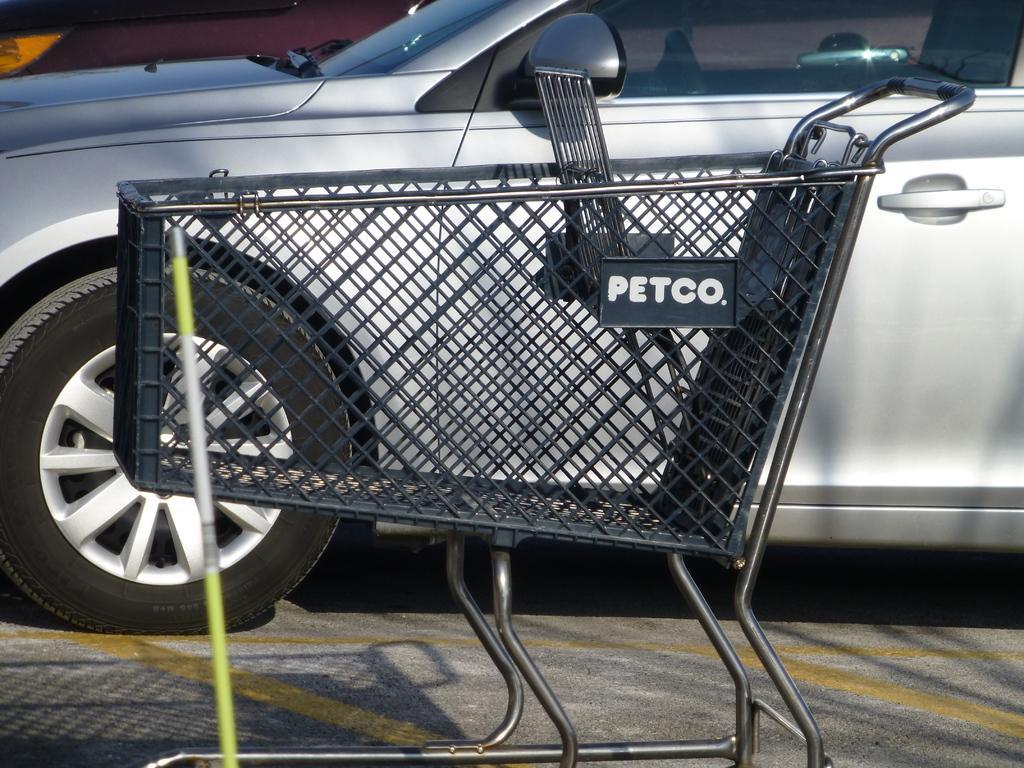How would you summarize this image in a sentence or two? In this image I can see a black colored trolley, a green and white colored object and a car which is ash in color on the ground. 